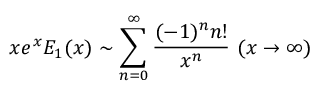Convert formula to latex. <formula><loc_0><loc_0><loc_500><loc_500>x e ^ { x } E _ { 1 } ( x ) \sim \sum _ { n = 0 } ^ { \infty } { \frac { ( - 1 ) ^ { n } n ! } { x ^ { n } } } \ ( x \to \infty )</formula> 